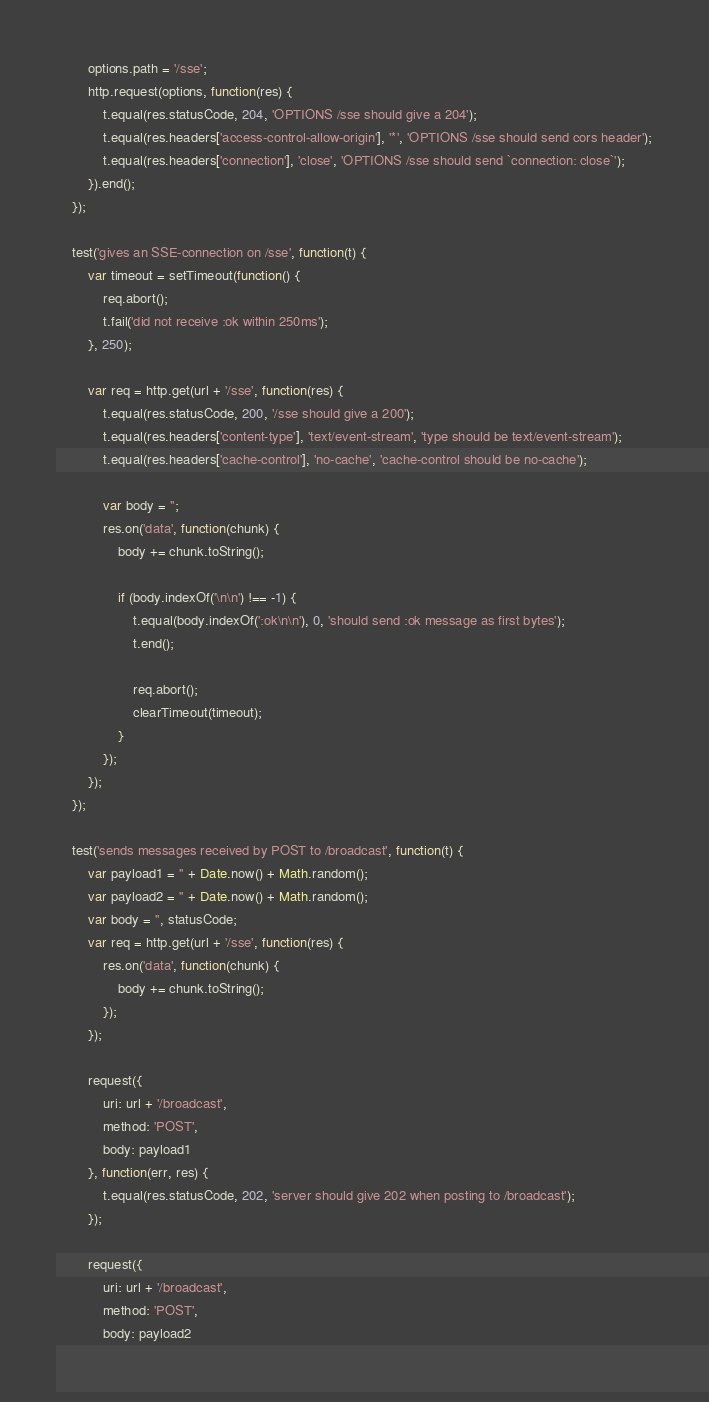Convert code to text. <code><loc_0><loc_0><loc_500><loc_500><_JavaScript_>        options.path = '/sse';
        http.request(options, function(res) {
            t.equal(res.statusCode, 204, 'OPTIONS /sse should give a 204');
            t.equal(res.headers['access-control-allow-origin'], '*', 'OPTIONS /sse should send cors header');
            t.equal(res.headers['connection'], 'close', 'OPTIONS /sse should send `connection: close`');
        }).end();
    });

    test('gives an SSE-connection on /sse', function(t) {
        var timeout = setTimeout(function() {
            req.abort();
            t.fail('did not receive :ok within 250ms');
        }, 250);

        var req = http.get(url + '/sse', function(res) {
            t.equal(res.statusCode, 200, '/sse should give a 200');
            t.equal(res.headers['content-type'], 'text/event-stream', 'type should be text/event-stream');
            t.equal(res.headers['cache-control'], 'no-cache', 'cache-control should be no-cache');

            var body = '';
            res.on('data', function(chunk) {
                body += chunk.toString();

                if (body.indexOf('\n\n') !== -1) {
                    t.equal(body.indexOf(':ok\n\n'), 0, 'should send :ok message as first bytes');
                    t.end();

                    req.abort();
                    clearTimeout(timeout);
                }
            });
        });
    });

    test('sends messages received by POST to /broadcast', function(t) {
        var payload1 = '' + Date.now() + Math.random();
        var payload2 = '' + Date.now() + Math.random();
        var body = '', statusCode;
        var req = http.get(url + '/sse', function(res) {
            res.on('data', function(chunk) {
                body += chunk.toString();
            });
        });

        request({
            uri: url + '/broadcast',
            method: 'POST',
            body: payload1
        }, function(err, res) {
            t.equal(res.statusCode, 202, 'server should give 202 when posting to /broadcast');
        });

        request({
            uri: url + '/broadcast',
            method: 'POST',
            body: payload2</code> 